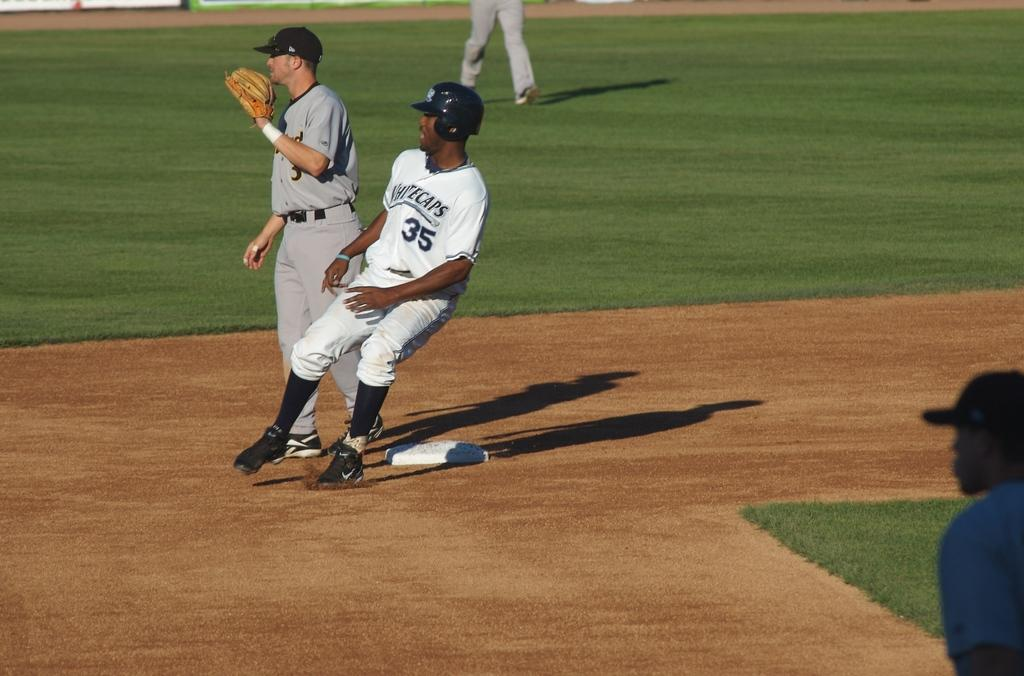<image>
Render a clear and concise summary of the photo. A baseball game featuring runner number 35 of the whitecaps. 